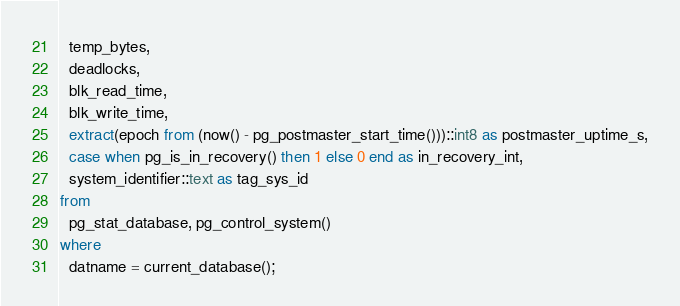<code> <loc_0><loc_0><loc_500><loc_500><_SQL_>  temp_bytes,
  deadlocks,
  blk_read_time,
  blk_write_time,
  extract(epoch from (now() - pg_postmaster_start_time()))::int8 as postmaster_uptime_s,
  case when pg_is_in_recovery() then 1 else 0 end as in_recovery_int,
  system_identifier::text as tag_sys_id
from
  pg_stat_database, pg_control_system()
where
  datname = current_database();
</code> 